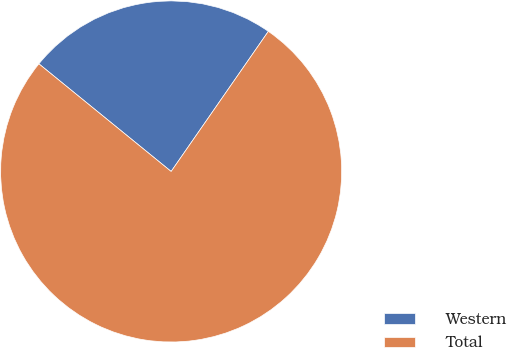Convert chart to OTSL. <chart><loc_0><loc_0><loc_500><loc_500><pie_chart><fcel>Western<fcel>Total<nl><fcel>23.78%<fcel>76.22%<nl></chart> 